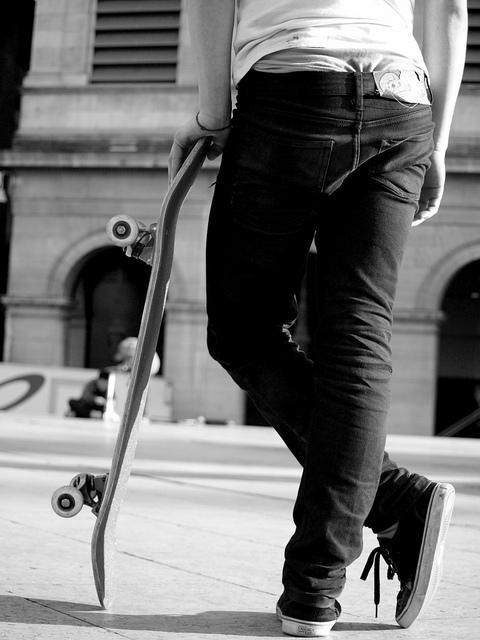What can the object the person is leaning on be used for? skating 